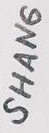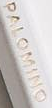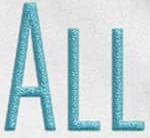What text is displayed in these images sequentially, separated by a semicolon? SHANG; PALOMINO; ALL 